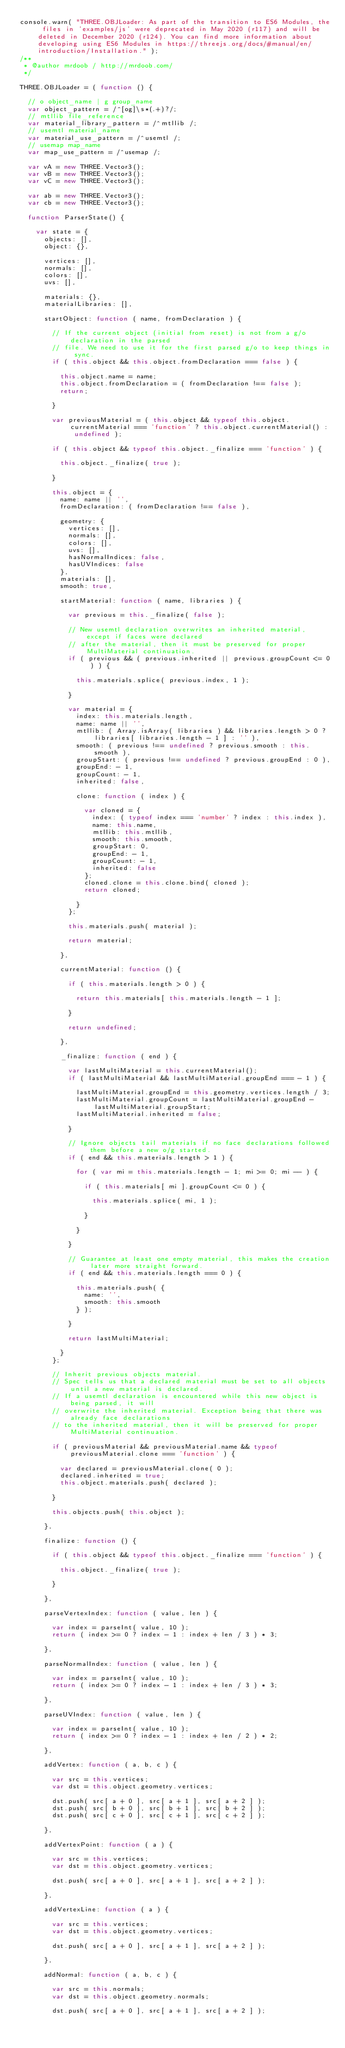<code> <loc_0><loc_0><loc_500><loc_500><_JavaScript_>console.warn( "THREE.OBJLoader: As part of the transition to ES6 Modules, the files in 'examples/js' were deprecated in May 2020 (r117) and will be deleted in December 2020 (r124). You can find more information about developing using ES6 Modules in https://threejs.org/docs/#manual/en/introduction/Installation." );
/**
 * @author mrdoob / http://mrdoob.com/
 */

THREE.OBJLoader = ( function () {

	// o object_name | g group_name
	var object_pattern = /^[og]\s*(.+)?/;
	// mtllib file_reference
	var material_library_pattern = /^mtllib /;
	// usemtl material_name
	var material_use_pattern = /^usemtl /;
	// usemap map_name
	var map_use_pattern = /^usemap /;

	var vA = new THREE.Vector3();
	var vB = new THREE.Vector3();
	var vC = new THREE.Vector3();

	var ab = new THREE.Vector3();
	var cb = new THREE.Vector3();

	function ParserState() {

		var state = {
			objects: [],
			object: {},

			vertices: [],
			normals: [],
			colors: [],
			uvs: [],

			materials: {},
			materialLibraries: [],

			startObject: function ( name, fromDeclaration ) {

				// If the current object (initial from reset) is not from a g/o declaration in the parsed
				// file. We need to use it for the first parsed g/o to keep things in sync.
				if ( this.object && this.object.fromDeclaration === false ) {

					this.object.name = name;
					this.object.fromDeclaration = ( fromDeclaration !== false );
					return;

				}

				var previousMaterial = ( this.object && typeof this.object.currentMaterial === 'function' ? this.object.currentMaterial() : undefined );

				if ( this.object && typeof this.object._finalize === 'function' ) {

					this.object._finalize( true );

				}

				this.object = {
					name: name || '',
					fromDeclaration: ( fromDeclaration !== false ),

					geometry: {
						vertices: [],
						normals: [],
						colors: [],
						uvs: [],
						hasNormalIndices: false,
						hasUVIndices: false
					},
					materials: [],
					smooth: true,

					startMaterial: function ( name, libraries ) {

						var previous = this._finalize( false );

						// New usemtl declaration overwrites an inherited material, except if faces were declared
						// after the material, then it must be preserved for proper MultiMaterial continuation.
						if ( previous && ( previous.inherited || previous.groupCount <= 0 ) ) {

							this.materials.splice( previous.index, 1 );

						}

						var material = {
							index: this.materials.length,
							name: name || '',
							mtllib: ( Array.isArray( libraries ) && libraries.length > 0 ? libraries[ libraries.length - 1 ] : '' ),
							smooth: ( previous !== undefined ? previous.smooth : this.smooth ),
							groupStart: ( previous !== undefined ? previous.groupEnd : 0 ),
							groupEnd: - 1,
							groupCount: - 1,
							inherited: false,

							clone: function ( index ) {

								var cloned = {
									index: ( typeof index === 'number' ? index : this.index ),
									name: this.name,
									mtllib: this.mtllib,
									smooth: this.smooth,
									groupStart: 0,
									groupEnd: - 1,
									groupCount: - 1,
									inherited: false
								};
								cloned.clone = this.clone.bind( cloned );
								return cloned;

							}
						};

						this.materials.push( material );

						return material;

					},

					currentMaterial: function () {

						if ( this.materials.length > 0 ) {

							return this.materials[ this.materials.length - 1 ];

						}

						return undefined;

					},

					_finalize: function ( end ) {

						var lastMultiMaterial = this.currentMaterial();
						if ( lastMultiMaterial && lastMultiMaterial.groupEnd === - 1 ) {

							lastMultiMaterial.groupEnd = this.geometry.vertices.length / 3;
							lastMultiMaterial.groupCount = lastMultiMaterial.groupEnd - lastMultiMaterial.groupStart;
							lastMultiMaterial.inherited = false;

						}

						// Ignore objects tail materials if no face declarations followed them before a new o/g started.
						if ( end && this.materials.length > 1 ) {

							for ( var mi = this.materials.length - 1; mi >= 0; mi -- ) {

								if ( this.materials[ mi ].groupCount <= 0 ) {

									this.materials.splice( mi, 1 );

								}

							}

						}

						// Guarantee at least one empty material, this makes the creation later more straight forward.
						if ( end && this.materials.length === 0 ) {

							this.materials.push( {
								name: '',
								smooth: this.smooth
							} );

						}

						return lastMultiMaterial;

					}
				};

				// Inherit previous objects material.
				// Spec tells us that a declared material must be set to all objects until a new material is declared.
				// If a usemtl declaration is encountered while this new object is being parsed, it will
				// overwrite the inherited material. Exception being that there was already face declarations
				// to the inherited material, then it will be preserved for proper MultiMaterial continuation.

				if ( previousMaterial && previousMaterial.name && typeof previousMaterial.clone === 'function' ) {

					var declared = previousMaterial.clone( 0 );
					declared.inherited = true;
					this.object.materials.push( declared );

				}

				this.objects.push( this.object );

			},

			finalize: function () {

				if ( this.object && typeof this.object._finalize === 'function' ) {

					this.object._finalize( true );

				}

			},

			parseVertexIndex: function ( value, len ) {

				var index = parseInt( value, 10 );
				return ( index >= 0 ? index - 1 : index + len / 3 ) * 3;

			},

			parseNormalIndex: function ( value, len ) {

				var index = parseInt( value, 10 );
				return ( index >= 0 ? index - 1 : index + len / 3 ) * 3;

			},

			parseUVIndex: function ( value, len ) {

				var index = parseInt( value, 10 );
				return ( index >= 0 ? index - 1 : index + len / 2 ) * 2;

			},

			addVertex: function ( a, b, c ) {

				var src = this.vertices;
				var dst = this.object.geometry.vertices;

				dst.push( src[ a + 0 ], src[ a + 1 ], src[ a + 2 ] );
				dst.push( src[ b + 0 ], src[ b + 1 ], src[ b + 2 ] );
				dst.push( src[ c + 0 ], src[ c + 1 ], src[ c + 2 ] );

			},

			addVertexPoint: function ( a ) {

				var src = this.vertices;
				var dst = this.object.geometry.vertices;

				dst.push( src[ a + 0 ], src[ a + 1 ], src[ a + 2 ] );

			},

			addVertexLine: function ( a ) {

				var src = this.vertices;
				var dst = this.object.geometry.vertices;

				dst.push( src[ a + 0 ], src[ a + 1 ], src[ a + 2 ] );

			},

			addNormal: function ( a, b, c ) {

				var src = this.normals;
				var dst = this.object.geometry.normals;

				dst.push( src[ a + 0 ], src[ a + 1 ], src[ a + 2 ] );</code> 